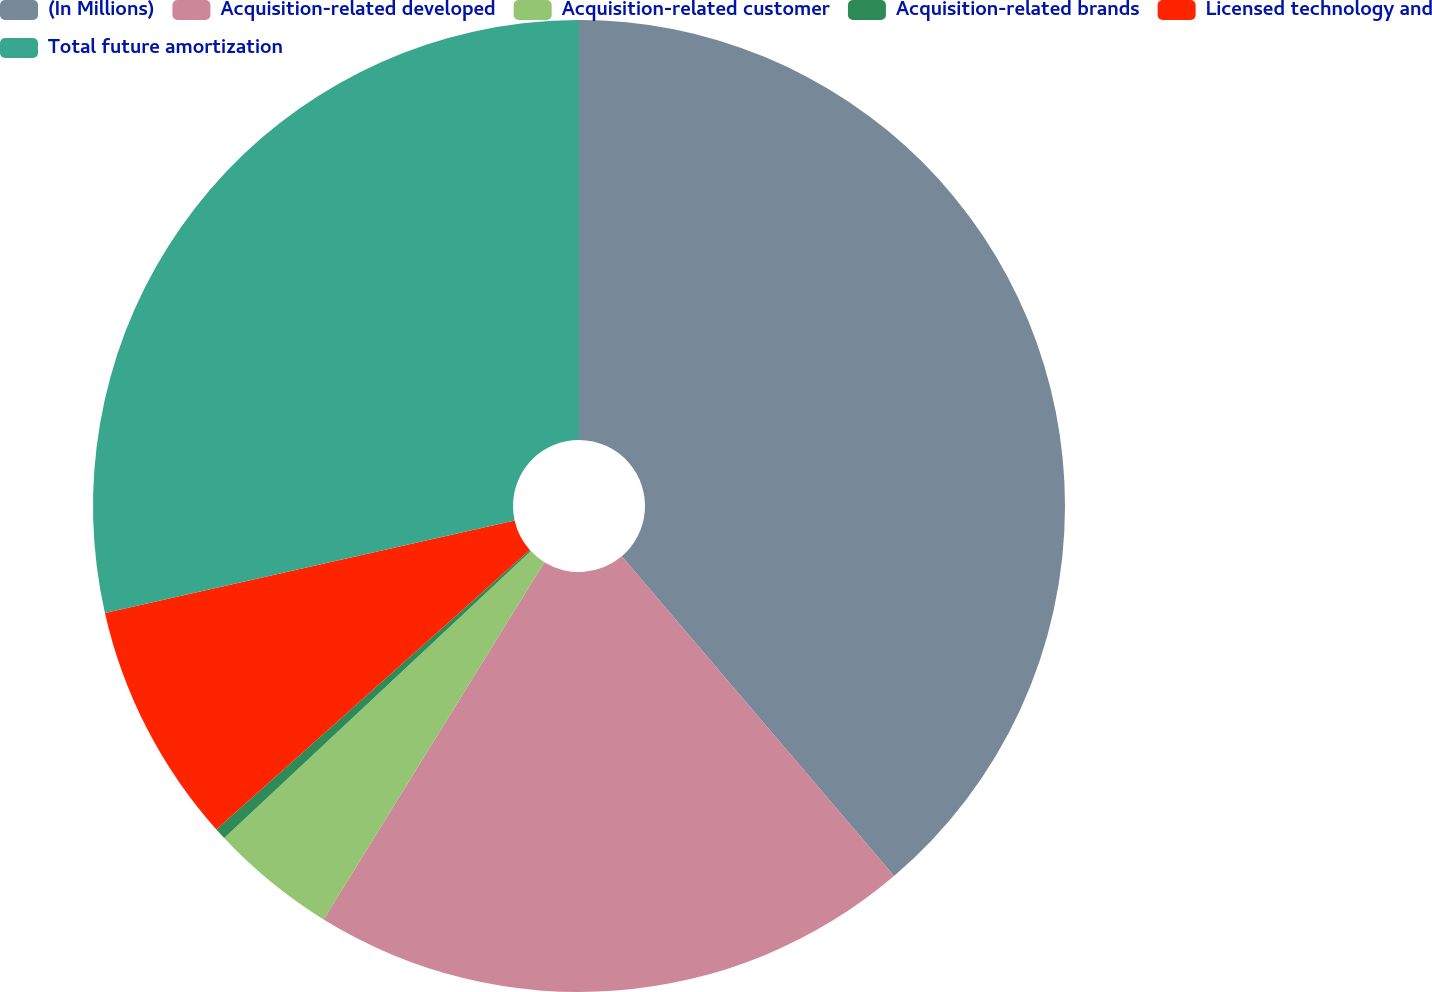Convert chart. <chart><loc_0><loc_0><loc_500><loc_500><pie_chart><fcel>(In Millions)<fcel>Acquisition-related developed<fcel>Acquisition-related customer<fcel>Acquisition-related brands<fcel>Licensed technology and<fcel>Total future amortization<nl><fcel>38.77%<fcel>20.03%<fcel>4.22%<fcel>0.38%<fcel>8.06%<fcel>28.53%<nl></chart> 